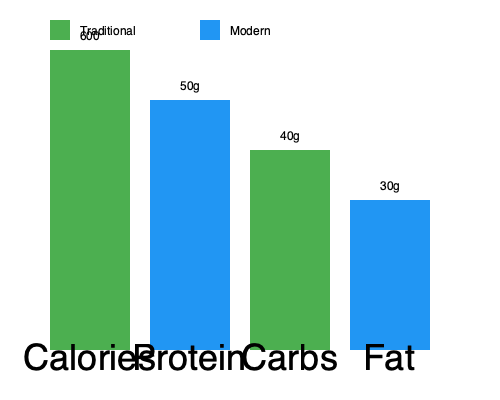Based on the nutritional content comparison between traditional and modern versions of a Croatian dish shown in the bar graph, which macronutrient has decreased the most in the modern version compared to the traditional recipe? To determine which macronutrient has decreased the most in the modern version compared to the traditional recipe, we need to analyze the differences for each macronutrient:

1. Calories: The traditional version has 600 calories, while the modern version has 500 calories. The difference is 100 calories.

2. Protein: The traditional version has 50g of protein, while the modern version has 50g as well. There is no difference in protein content.

3. Carbohydrates: The traditional version has 40g of carbs, while the modern version has 30g. The difference is 10g of carbs.

4. Fat: The traditional version has 30g of fat, while the modern version has 20g. The difference is 10g of fat.

Comparing the differences:
- Calories: 100 calorie decrease
- Protein: No change
- Carbohydrates: 10g decrease
- Fat: 10g decrease

While both carbohydrates and fat have decreased by the same amount (10g), we need to consider the percentage change relative to their original values:

- Carbohydrates: 10g decrease from 40g is a 25% reduction
- Fat: 10g decrease from 30g is a 33.33% reduction

Therefore, fat has decreased the most in terms of percentage change from the traditional to the modern version of the dish.
Answer: Fat 